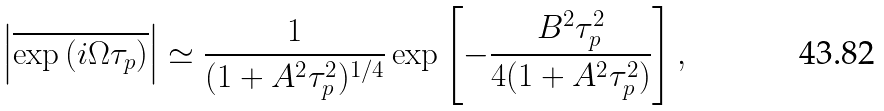<formula> <loc_0><loc_0><loc_500><loc_500>\left | \overline { \exp \left ( i \Omega \tau _ { p } \right ) } \right | \simeq \frac { 1 } { ( 1 + A ^ { 2 } \tau _ { p } ^ { 2 } ) ^ { 1 / 4 } } \exp \left [ - \frac { B ^ { 2 } \tau _ { p } ^ { 2 } } { 4 ( 1 + A ^ { 2 } \tau _ { p } ^ { 2 } ) } \right ] ,</formula> 